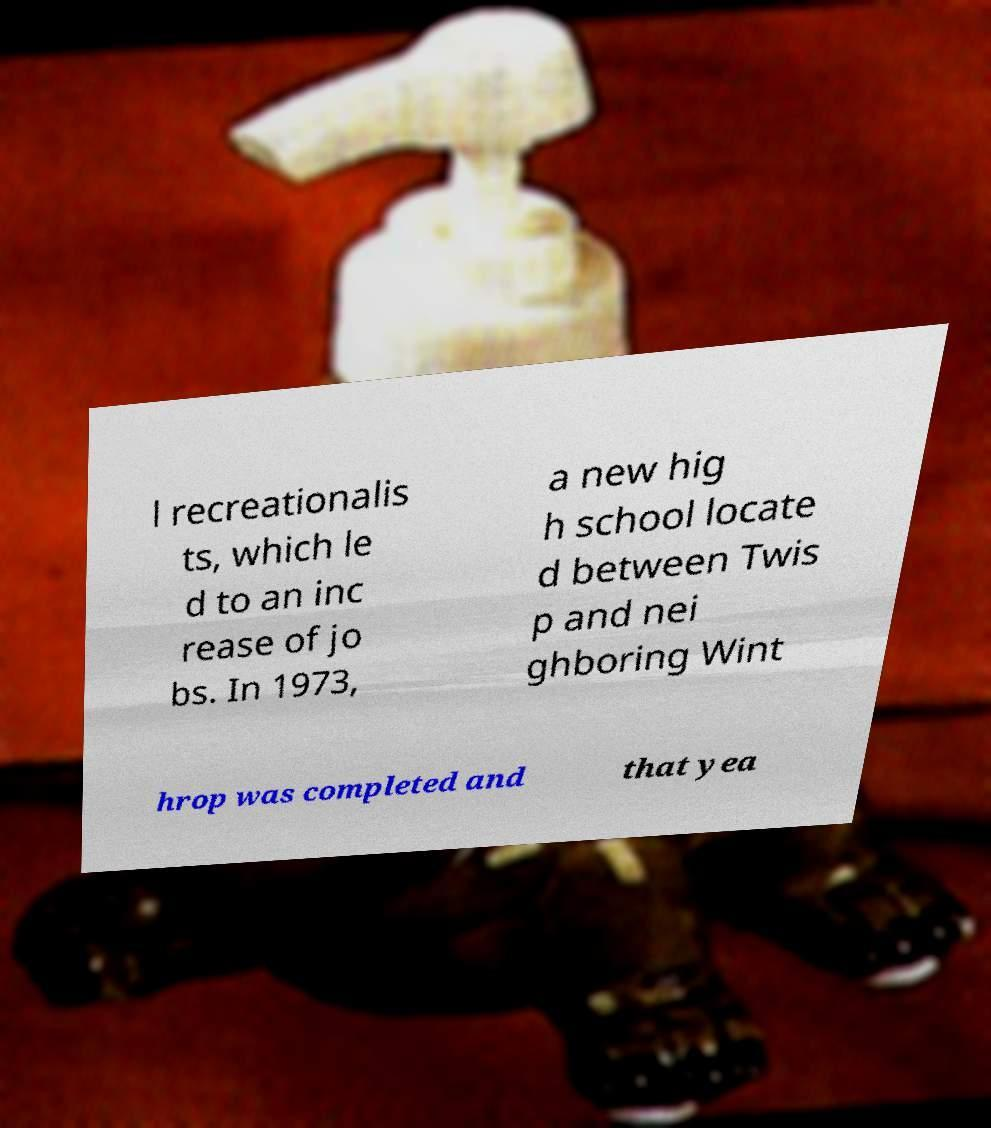Could you assist in decoding the text presented in this image and type it out clearly? l recreationalis ts, which le d to an inc rease of jo bs. In 1973, a new hig h school locate d between Twis p and nei ghboring Wint hrop was completed and that yea 